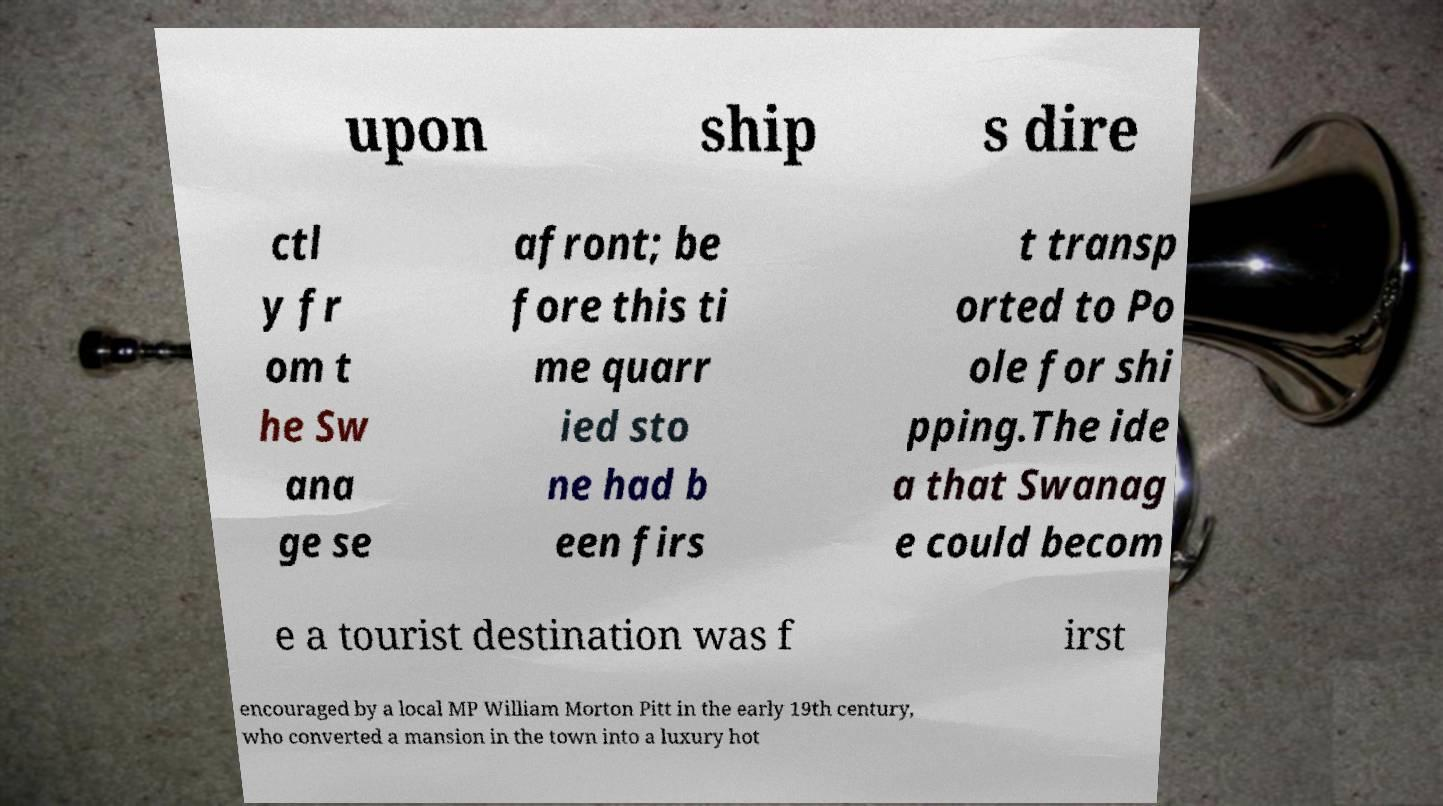There's text embedded in this image that I need extracted. Can you transcribe it verbatim? upon ship s dire ctl y fr om t he Sw ana ge se afront; be fore this ti me quarr ied sto ne had b een firs t transp orted to Po ole for shi pping.The ide a that Swanag e could becom e a tourist destination was f irst encouraged by a local MP William Morton Pitt in the early 19th century, who converted a mansion in the town into a luxury hot 